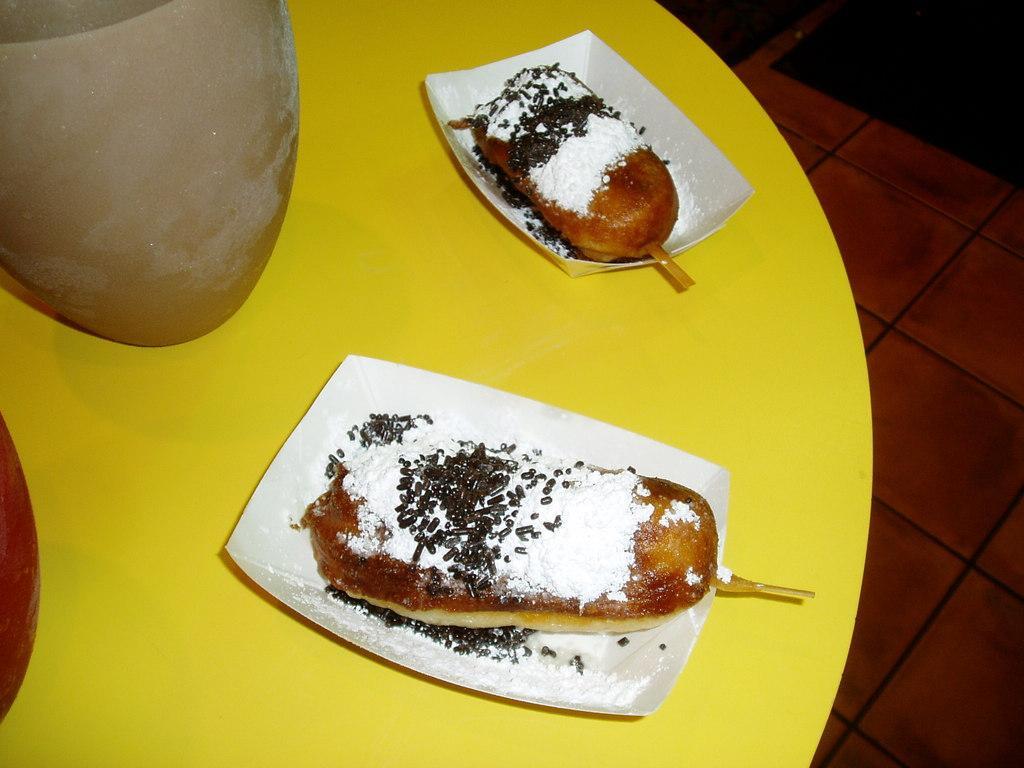Can you describe this image briefly? In the center of the image there is a table. On the table we can see glasses which contains liquid and some food item are present on the plate. On the right side of the image there is a floor. 